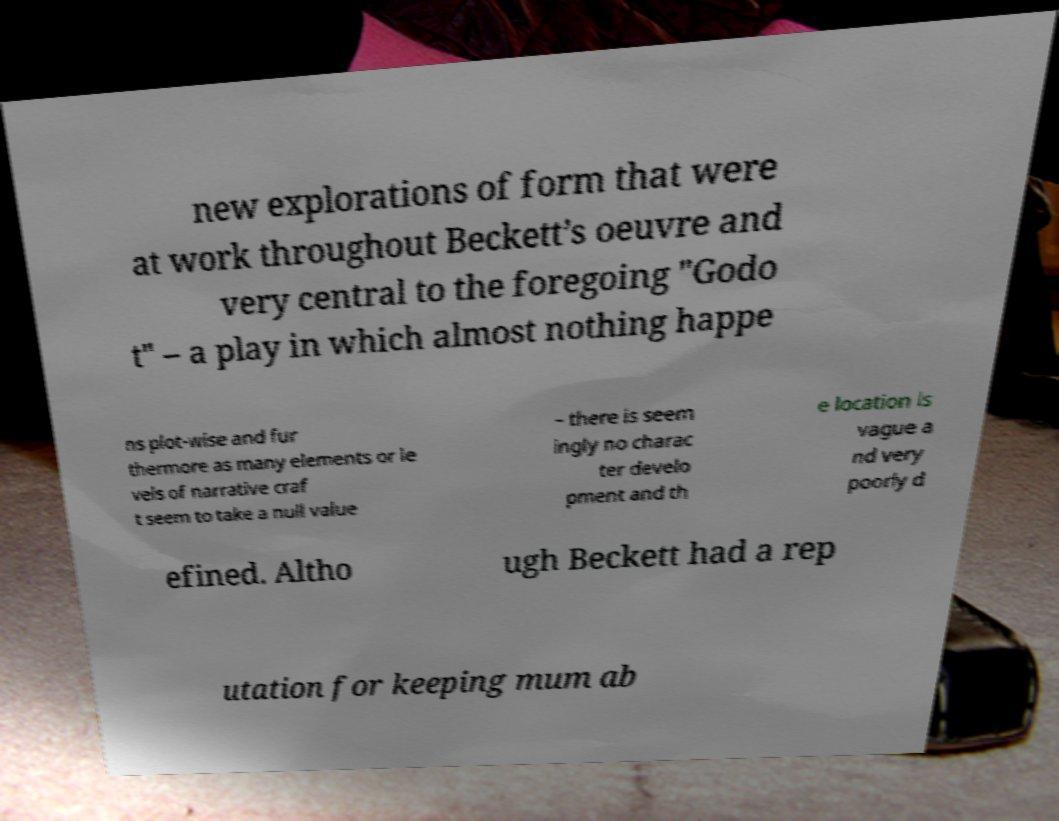Please read and relay the text visible in this image. What does it say? new explorations of form that were at work throughout Beckett’s oeuvre and very central to the foregoing "Godo t" – a play in which almost nothing happe ns plot-wise and fur thermore as many elements or le vels of narrative craf t seem to take a null value – there is seem ingly no charac ter develo pment and th e location is vague a nd very poorly d efined. Altho ugh Beckett had a rep utation for keeping mum ab 